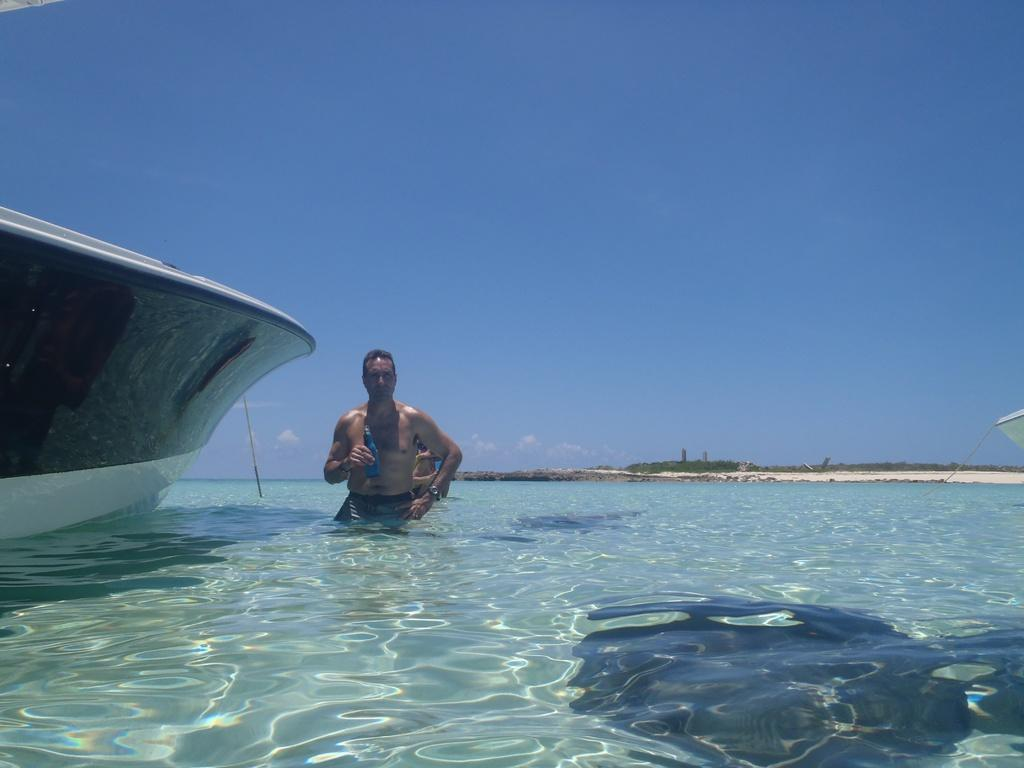How many people are in the water in the image? There are two people in the water in the image. What is located on the left side of the image? There is a boat on the left side of the image. What can be seen in the background of the image? There are trees and the sky visible in the background of the image. How does the water level increase in the image? There is no indication of the water level changing in the image. What type of book is the person reading in the image? There is no person reading a book in the image. What is the pail used for in the image? There is no pail present in the image. 